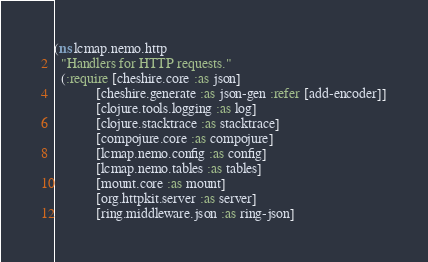Convert code to text. <code><loc_0><loc_0><loc_500><loc_500><_Clojure_>(ns lcmap.nemo.http
  "Handlers for HTTP requests."
  (:require [cheshire.core :as json]
            [cheshire.generate :as json-gen :refer [add-encoder]]
            [clojure.tools.logging :as log]
            [clojure.stacktrace :as stacktrace]
            [compojure.core :as compojure]
            [lcmap.nemo.config :as config]
            [lcmap.nemo.tables :as tables]
            [mount.core :as mount]
            [org.httpkit.server :as server]
            [ring.middleware.json :as ring-json]</code> 